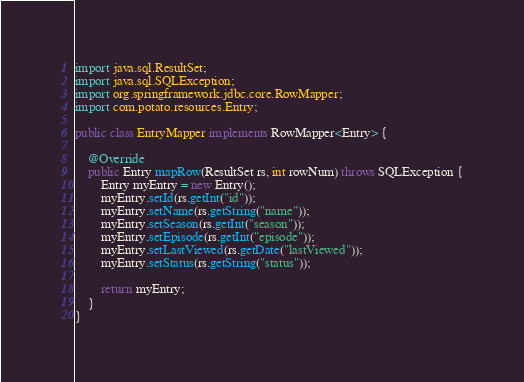Convert code to text. <code><loc_0><loc_0><loc_500><loc_500><_Java_>
import java.sql.ResultSet;
import java.sql.SQLException;
import org.springframework.jdbc.core.RowMapper;
import com.potato.resources.Entry;

public class EntryMapper implements RowMapper<Entry> {
	
	@Override
	public Entry mapRow(ResultSet rs, int rowNum) throws SQLException {
		Entry myEntry = new Entry();
		myEntry.setId(rs.getInt("id"));
		myEntry.setName(rs.getString("name"));
		myEntry.setSeason(rs.getInt("season"));
		myEntry.setEpisode(rs.getInt("episode"));
		myEntry.setLastViewed(rs.getDate("lastViewed"));
		myEntry.setStatus(rs.getString("status"));
		
		return myEntry;
	}
}
</code> 